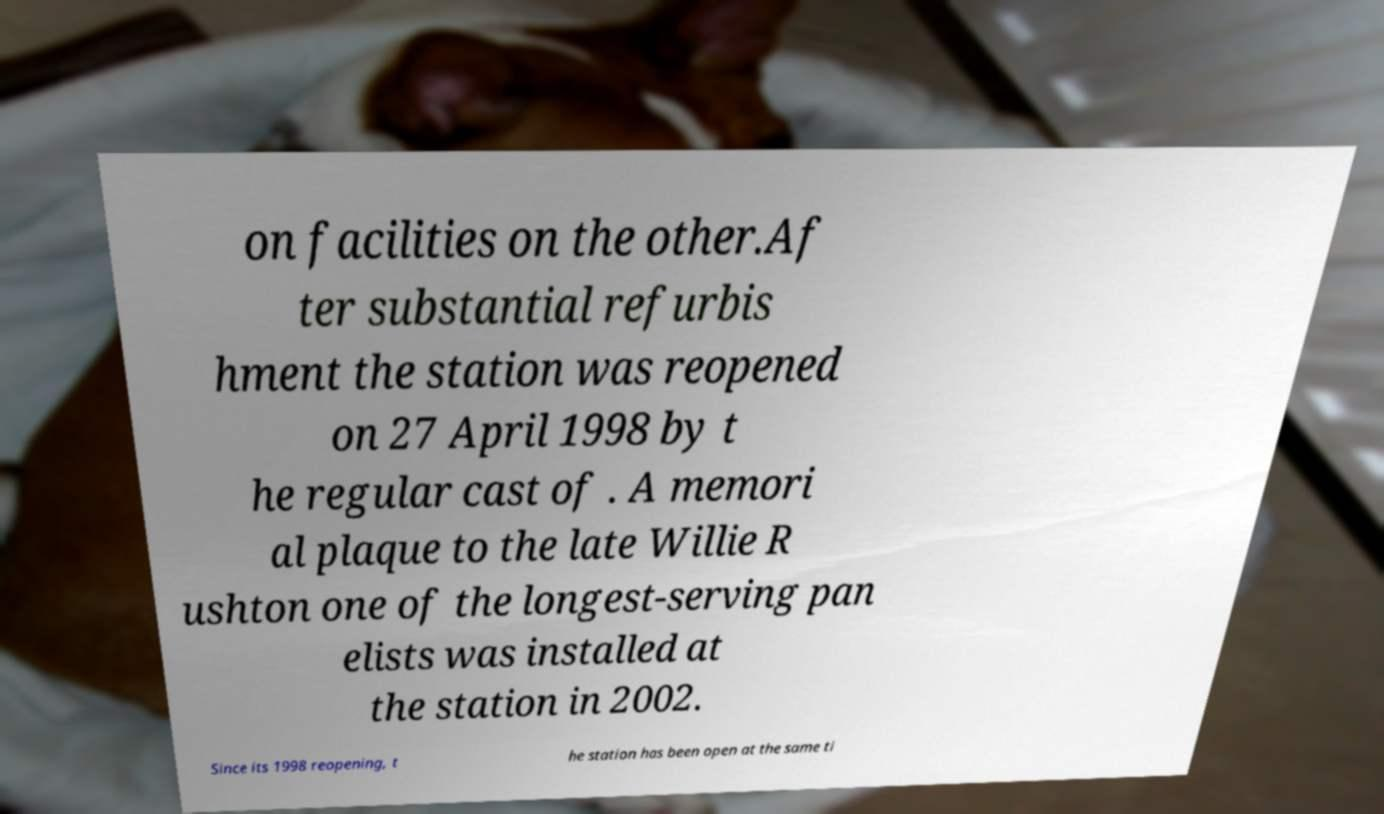Please read and relay the text visible in this image. What does it say? on facilities on the other.Af ter substantial refurbis hment the station was reopened on 27 April 1998 by t he regular cast of . A memori al plaque to the late Willie R ushton one of the longest-serving pan elists was installed at the station in 2002. Since its 1998 reopening, t he station has been open at the same ti 